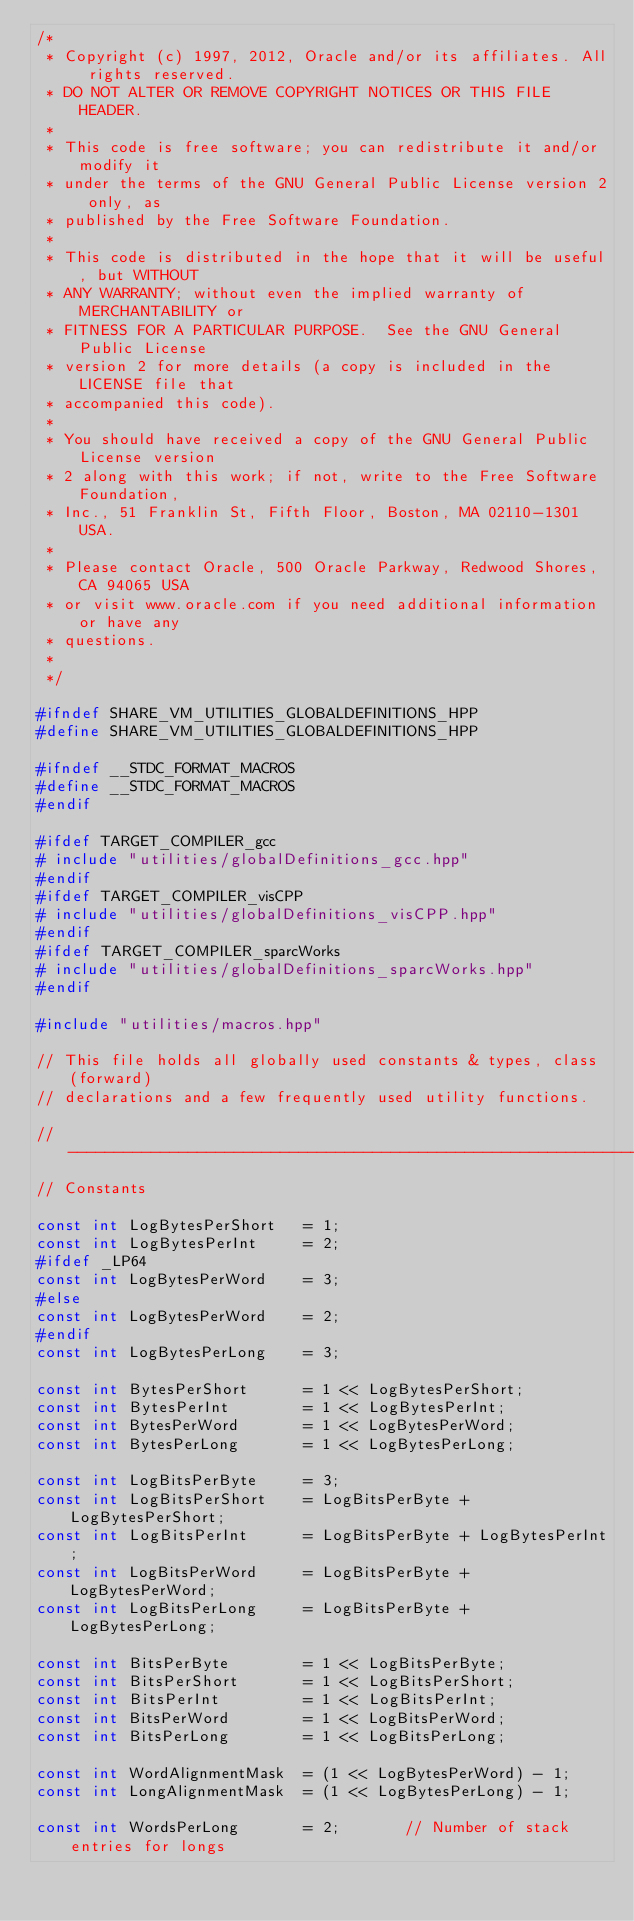<code> <loc_0><loc_0><loc_500><loc_500><_C++_>/*
 * Copyright (c) 1997, 2012, Oracle and/or its affiliates. All rights reserved.
 * DO NOT ALTER OR REMOVE COPYRIGHT NOTICES OR THIS FILE HEADER.
 *
 * This code is free software; you can redistribute it and/or modify it
 * under the terms of the GNU General Public License version 2 only, as
 * published by the Free Software Foundation.
 *
 * This code is distributed in the hope that it will be useful, but WITHOUT
 * ANY WARRANTY; without even the implied warranty of MERCHANTABILITY or
 * FITNESS FOR A PARTICULAR PURPOSE.  See the GNU General Public License
 * version 2 for more details (a copy is included in the LICENSE file that
 * accompanied this code).
 *
 * You should have received a copy of the GNU General Public License version
 * 2 along with this work; if not, write to the Free Software Foundation,
 * Inc., 51 Franklin St, Fifth Floor, Boston, MA 02110-1301 USA.
 *
 * Please contact Oracle, 500 Oracle Parkway, Redwood Shores, CA 94065 USA
 * or visit www.oracle.com if you need additional information or have any
 * questions.
 *
 */

#ifndef SHARE_VM_UTILITIES_GLOBALDEFINITIONS_HPP
#define SHARE_VM_UTILITIES_GLOBALDEFINITIONS_HPP

#ifndef __STDC_FORMAT_MACROS
#define __STDC_FORMAT_MACROS
#endif

#ifdef TARGET_COMPILER_gcc
# include "utilities/globalDefinitions_gcc.hpp"
#endif
#ifdef TARGET_COMPILER_visCPP
# include "utilities/globalDefinitions_visCPP.hpp"
#endif
#ifdef TARGET_COMPILER_sparcWorks
# include "utilities/globalDefinitions_sparcWorks.hpp"
#endif

#include "utilities/macros.hpp"

// This file holds all globally used constants & types, class (forward)
// declarations and a few frequently used utility functions.

//----------------------------------------------------------------------------------------------------
// Constants

const int LogBytesPerShort   = 1;
const int LogBytesPerInt     = 2;
#ifdef _LP64
const int LogBytesPerWord    = 3;
#else
const int LogBytesPerWord    = 2;
#endif
const int LogBytesPerLong    = 3;

const int BytesPerShort      = 1 << LogBytesPerShort;
const int BytesPerInt        = 1 << LogBytesPerInt;
const int BytesPerWord       = 1 << LogBytesPerWord;
const int BytesPerLong       = 1 << LogBytesPerLong;

const int LogBitsPerByte     = 3;
const int LogBitsPerShort    = LogBitsPerByte + LogBytesPerShort;
const int LogBitsPerInt      = LogBitsPerByte + LogBytesPerInt;
const int LogBitsPerWord     = LogBitsPerByte + LogBytesPerWord;
const int LogBitsPerLong     = LogBitsPerByte + LogBytesPerLong;

const int BitsPerByte        = 1 << LogBitsPerByte;
const int BitsPerShort       = 1 << LogBitsPerShort;
const int BitsPerInt         = 1 << LogBitsPerInt;
const int BitsPerWord        = 1 << LogBitsPerWord;
const int BitsPerLong        = 1 << LogBitsPerLong;

const int WordAlignmentMask  = (1 << LogBytesPerWord) - 1;
const int LongAlignmentMask  = (1 << LogBytesPerLong) - 1;

const int WordsPerLong       = 2;       // Number of stack entries for longs
</code> 